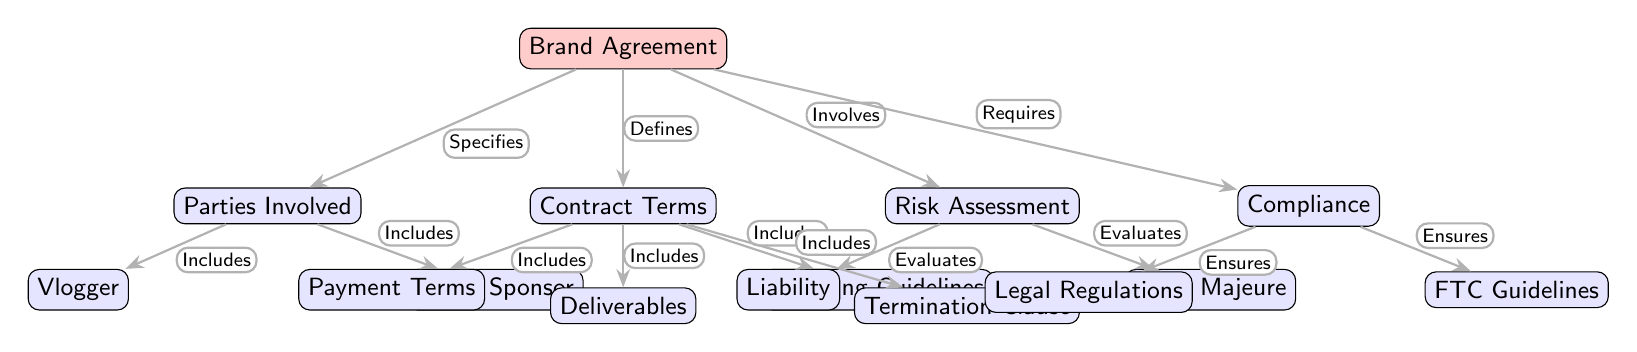What is the main subject of the diagram? The main subject, identifiable at the top of the diagram, is labeled as "Brand Agreement." This serves as the focal point from which other elements branch out.
Answer: Brand Agreement How many parties are involved in the agreement? The node labeled "Parties Involved" indicates that there are two parties, specifically a "Vlogger" and a "Brand Sponsor," both included under this node.
Answer: Two What are the two components evaluated under Risk Assessment? Under the "Risk Assessment" node, the sub-nodes are "Liability" and "Force Majeure," both of which are specified as the elements that are evaluated in this section.
Answer: Liability and Force Majeure Which element defines the contractual terms? The node directly connected to "Contract Terms" is "Brand Agreement," which defines all the subsequent details regarding the terms of the contract.
Answer: Brand Agreement What do the legal compliance factors ensure? The "Compliance" node describes two aspects that ensure adherence to regulations: "Legal Regulations" and "FTC Guidelines," which are clearly stated as the requirements under compliance.
Answer: Legal Regulations and FTC Guidelines Which financial aspect is included in the contract terms? The "Payment Terms" is explicitly listed under the "Contract Terms," indicating that financial considerations are a critical part of the agreement.
Answer: Payment Terms What is required for the brand agreement to take effect? The "Compliance" node indicates that compliance is a necessary condition for the validity and enforcement of the brand agreement as a whole.
Answer: Compliance Which clause relates to the termination of the agreement? The "Termination Clause" is specified under the “Contract Terms,” demonstrating its significance in establishing conditions under which the agreement can be ended.
Answer: Termination Clause What is the purpose of the compliance elements in the diagram? The elements of compliance, namely "Legal Regulations" and "FTC Guidelines," serve the purpose of ensuring that the brand agreement meets required legal standards and advertising practices.
Answer: Ensures legal standards 